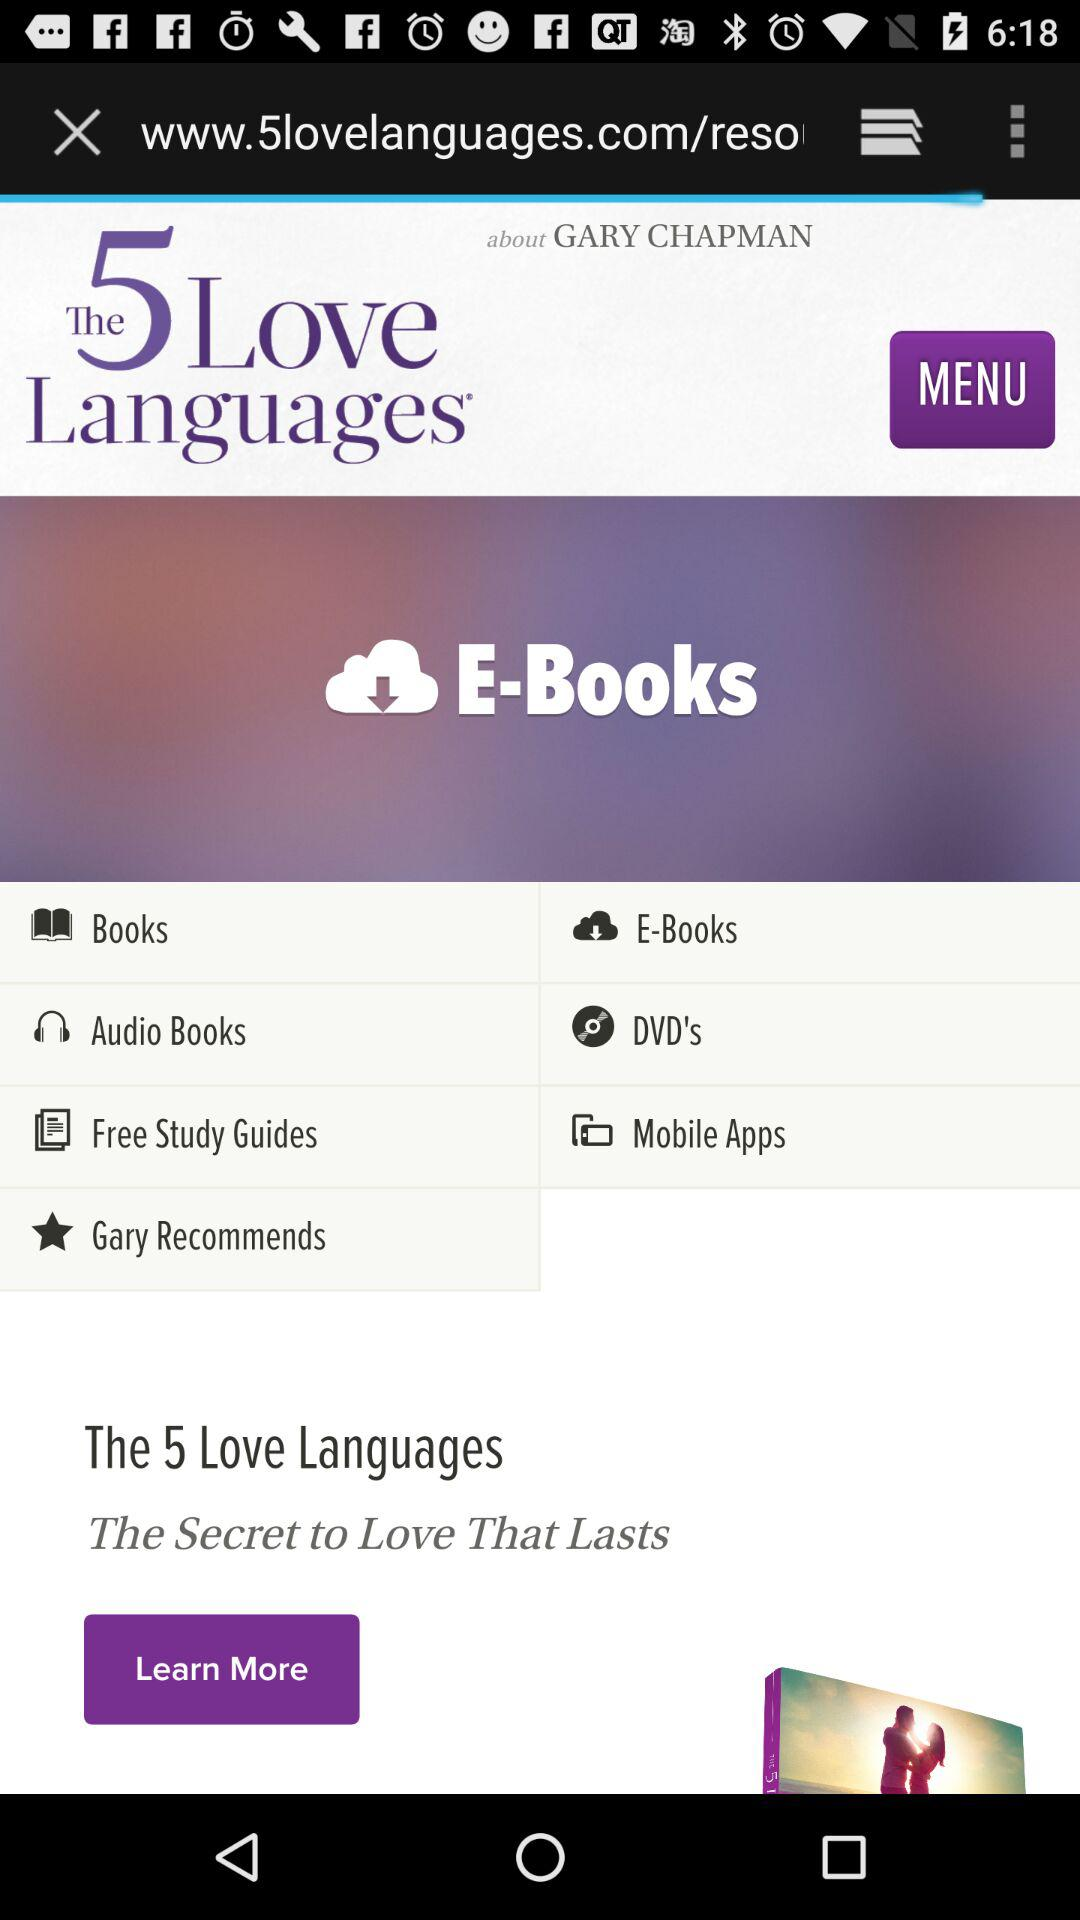What is the name of the book? The name of the book is "The 5 Love Languages". 